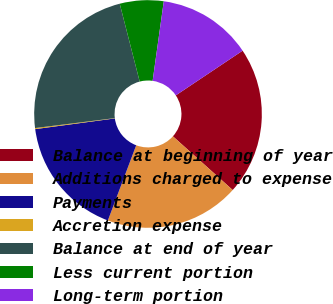Convert chart. <chart><loc_0><loc_0><loc_500><loc_500><pie_chart><fcel>Balance at beginning of year<fcel>Additions charged to expense<fcel>Payments<fcel>Accretion expense<fcel>Balance at end of year<fcel>Less current portion<fcel>Long-term portion<nl><fcel>21.03%<fcel>19.09%<fcel>17.14%<fcel>0.15%<fcel>22.98%<fcel>6.21%<fcel>13.4%<nl></chart> 